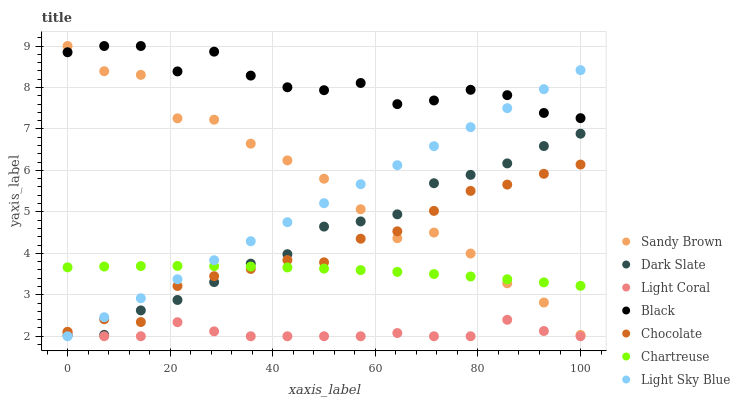Does Light Coral have the minimum area under the curve?
Answer yes or no. Yes. Does Black have the maximum area under the curve?
Answer yes or no. Yes. Does Dark Slate have the minimum area under the curve?
Answer yes or no. No. Does Dark Slate have the maximum area under the curve?
Answer yes or no. No. Is Light Sky Blue the smoothest?
Answer yes or no. Yes. Is Black the roughest?
Answer yes or no. Yes. Is Light Coral the smoothest?
Answer yes or no. No. Is Light Coral the roughest?
Answer yes or no. No. Does Light Coral have the lowest value?
Answer yes or no. Yes. Does Dark Slate have the lowest value?
Answer yes or no. No. Does Sandy Brown have the highest value?
Answer yes or no. Yes. Does Dark Slate have the highest value?
Answer yes or no. No. Is Dark Slate less than Black?
Answer yes or no. Yes. Is Black greater than Light Coral?
Answer yes or no. Yes. Does Light Sky Blue intersect Chartreuse?
Answer yes or no. Yes. Is Light Sky Blue less than Chartreuse?
Answer yes or no. No. Is Light Sky Blue greater than Chartreuse?
Answer yes or no. No. Does Dark Slate intersect Black?
Answer yes or no. No. 